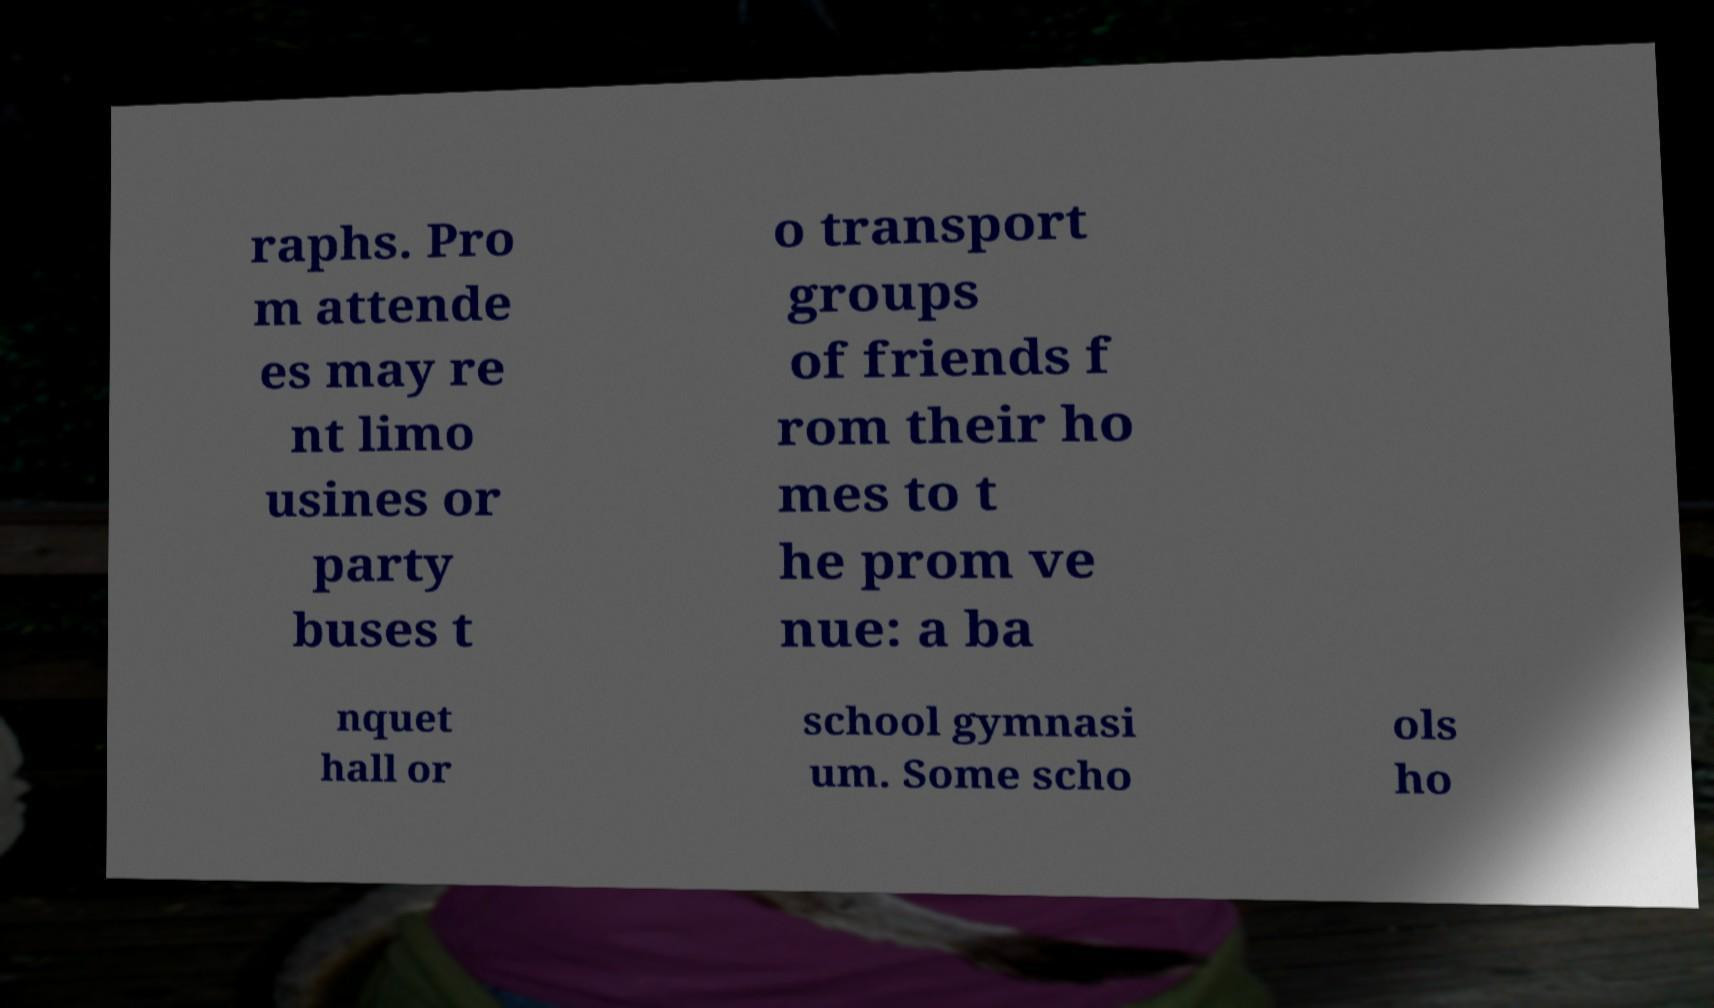What messages or text are displayed in this image? I need them in a readable, typed format. raphs. Pro m attende es may re nt limo usines or party buses t o transport groups of friends f rom their ho mes to t he prom ve nue: a ba nquet hall or school gymnasi um. Some scho ols ho 